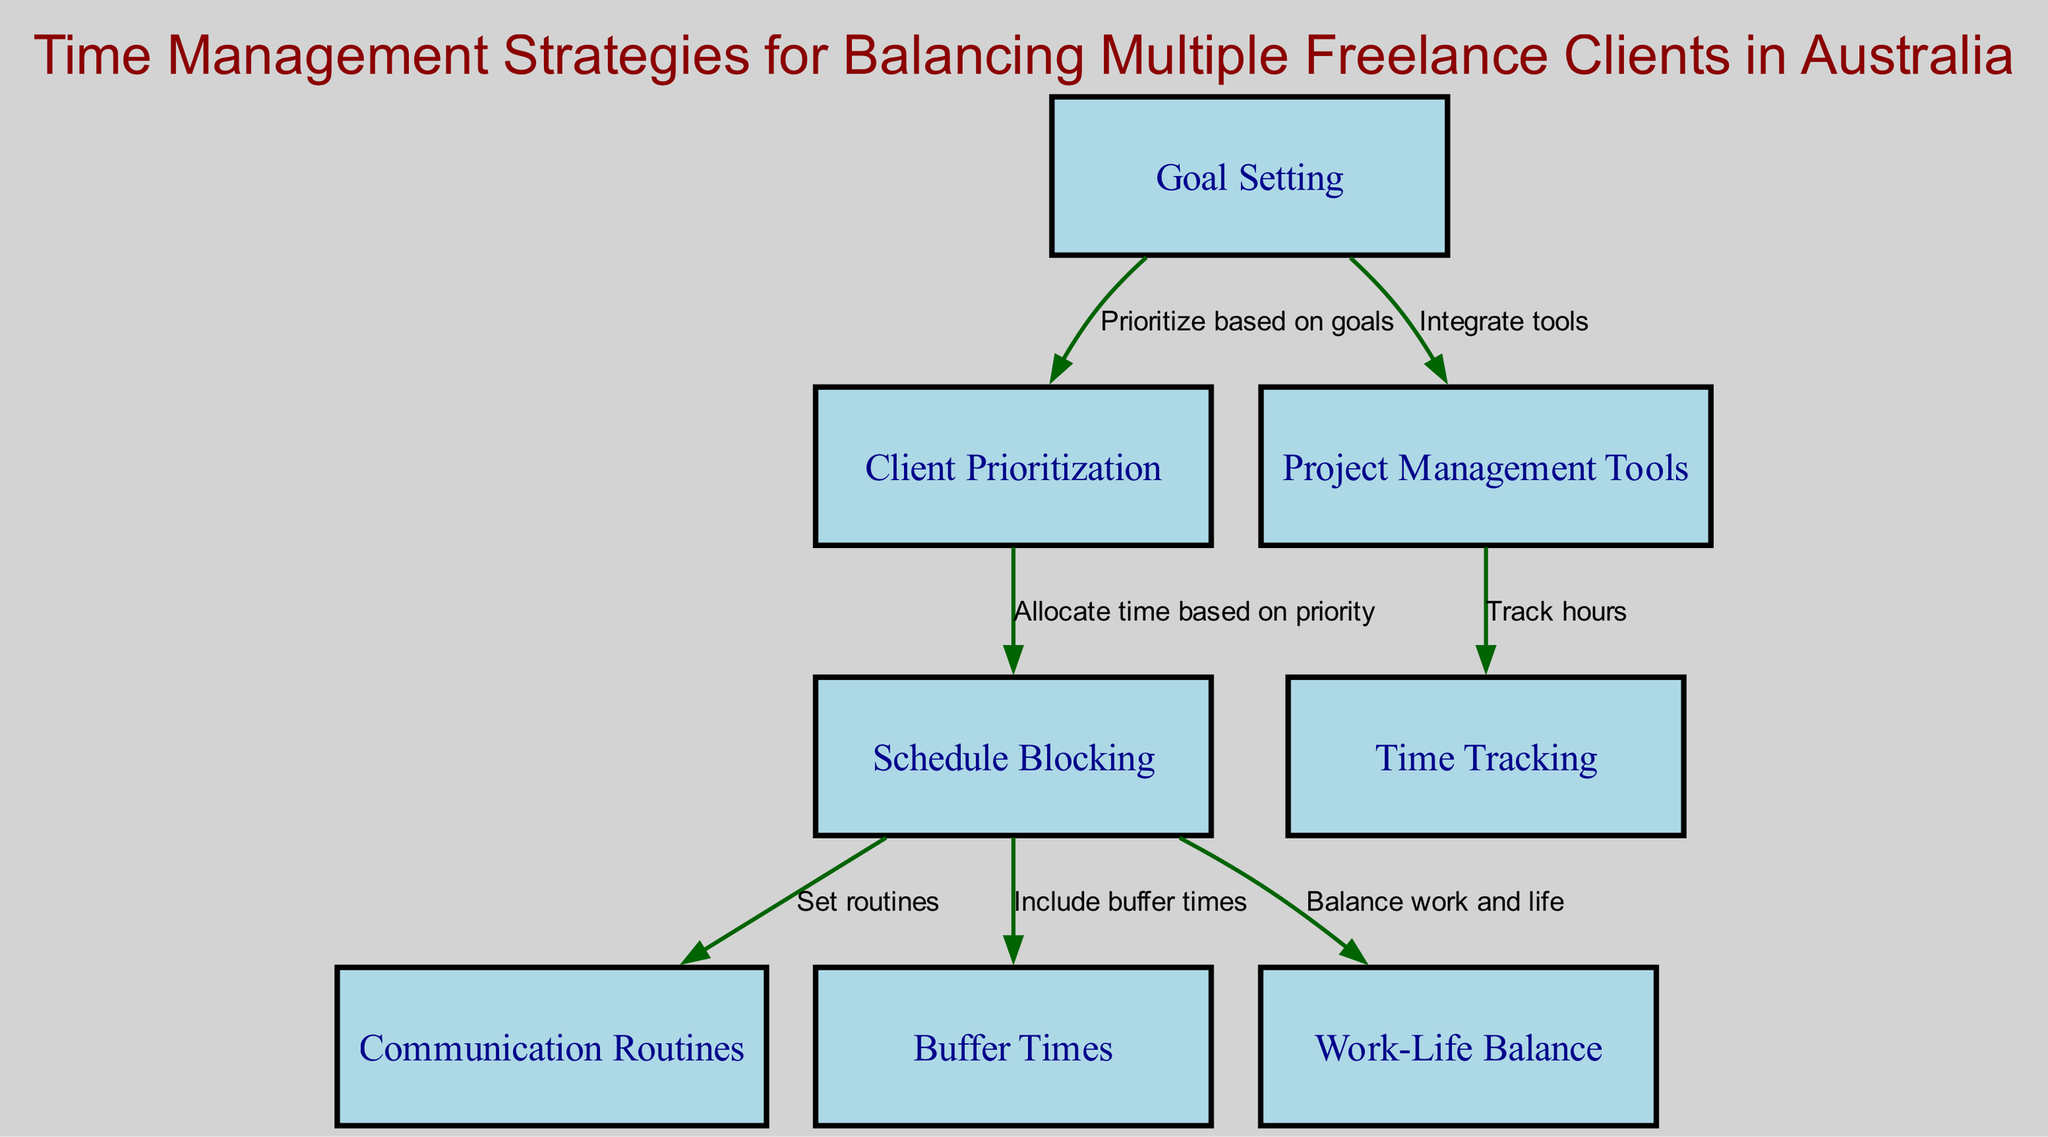What is the first element in the diagram? The first element listed in the data under "elements" is "Goal Setting." It is the first node presented in the diagram.
Answer: Goal Setting How many elements are there in the diagram? The number of elements is given as 8 in the provided data under "elements." Each entry represents a unique time management strategy.
Answer: 8 What are the primary tools suggested for project management? The primary tools suggested for project management are "Trello" and "Asana." This information can be found in the description of the "Project Management Tools" node.
Answer: Trello or Asana Which two nodes are connected by the label "Set routines"? The nodes "Schedule Blocking" and "Communication Routines" are connected by the label "Set routines." This connection indicates a relationship in the diagram specifying how schedule blocking relates to communication routines.
Answer: Schedule Blocking and Communication Routines What is the purpose of buffer times in the schedule blocking? The purpose of buffer times in schedule blocking is to "Allocate buffer times to handle unexpected tasks or delays." This is specifically stated in the description of the "Buffer Times" element.
Answer: Handle unexpected tasks or delays Which element is directly connected to both "Goal Setting" and "Schedule Blocking"? The element "Client Prioritization" is directly connected to both "Goal Setting" (prioritized based on goals) and "Schedule Blocking" (allocate time based on priority). This indicates the sequence in which tasks should be approached.
Answer: Client Prioritization What is indicated to be essential for maintaining balance in the work-life equation? "Work-Life Balance" is indicated as essential for maintaining balance. It emphasizes the need to schedule time for breaks and personal activities to ensure overall well-being.
Answer: Schedule time for breaks and personal activities Which element follows "Project Management Tools" based on time tracking? The element that follows "Project Management Tools" based on time tracking is "Time Tracking." This suggests that after utilizing project management tools, tracking time is necessary for effective management of client work.
Answer: Time Tracking 